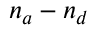<formula> <loc_0><loc_0><loc_500><loc_500>n _ { a } - n _ { d }</formula> 